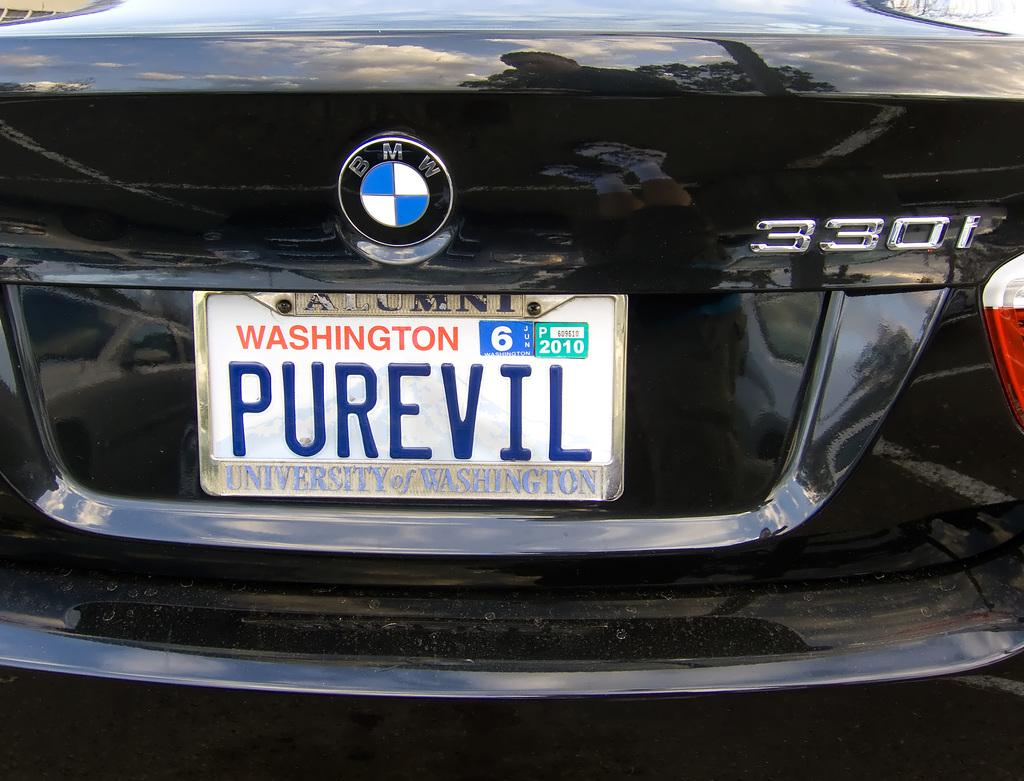<image>
Present a compact description of the photo's key features. The University of Washington alumni and BMW 330i owner has a license plate that says "Pure Evil" 